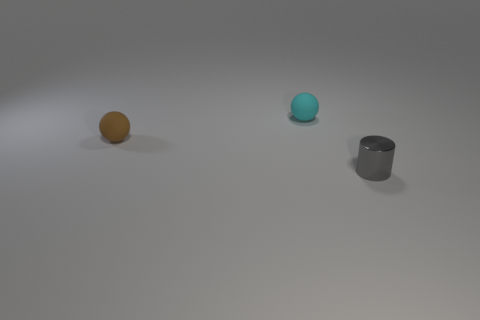The cyan ball that is made of the same material as the brown sphere is what size?
Offer a terse response. Small. Are there any small shiny balls of the same color as the tiny metallic cylinder?
Provide a short and direct response. No. There is a cyan matte thing; does it have the same size as the object that is to the left of the cyan rubber object?
Provide a succinct answer. Yes. There is a tiny object on the right side of the matte sphere that is right of the tiny brown thing; how many brown matte things are right of it?
Provide a succinct answer. 0. Are there any cyan balls to the left of the cyan rubber thing?
Ensure brevity in your answer.  No. What shape is the small gray thing?
Keep it short and to the point. Cylinder. The small gray object in front of the small ball in front of the sphere that is on the right side of the tiny brown ball is what shape?
Your answer should be very brief. Cylinder. What number of other things are the same shape as the brown thing?
Your answer should be very brief. 1. There is a tiny sphere right of the tiny thing that is left of the cyan thing; what is its material?
Keep it short and to the point. Rubber. Is there anything else that has the same size as the brown matte sphere?
Offer a terse response. Yes. 